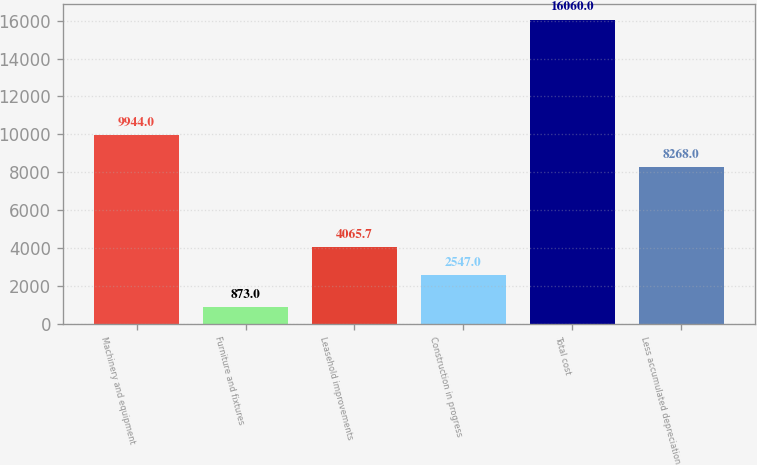Convert chart. <chart><loc_0><loc_0><loc_500><loc_500><bar_chart><fcel>Machinery and equipment<fcel>Furniture and fixtures<fcel>Leasehold improvements<fcel>Construction in progress<fcel>Total cost<fcel>Less accumulated depreciation<nl><fcel>9944<fcel>873<fcel>4065.7<fcel>2547<fcel>16060<fcel>8268<nl></chart> 